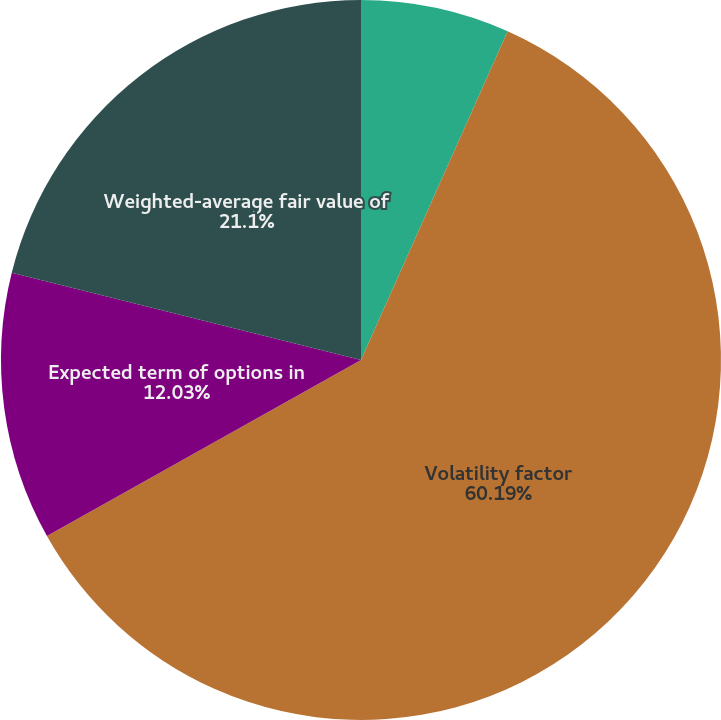<chart> <loc_0><loc_0><loc_500><loc_500><pie_chart><fcel>Risk-free interest rate<fcel>Volatility factor<fcel>Expected term of options in<fcel>Weighted-average fair value of<nl><fcel>6.68%<fcel>60.19%<fcel>12.03%<fcel>21.1%<nl></chart> 